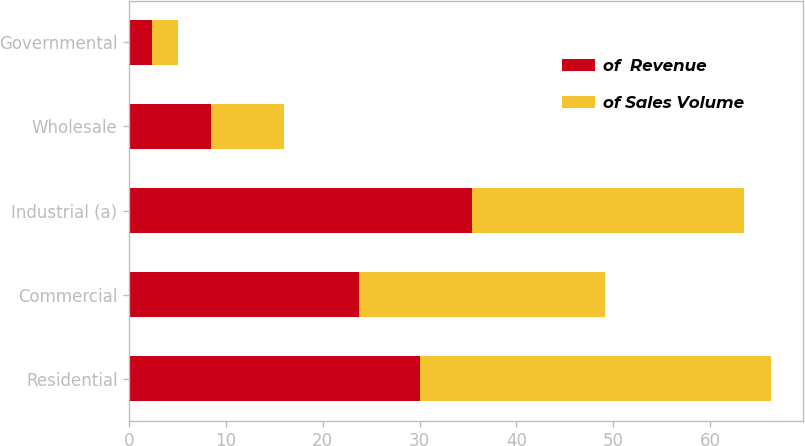<chart> <loc_0><loc_0><loc_500><loc_500><stacked_bar_chart><ecel><fcel>Residential<fcel>Commercial<fcel>Industrial (a)<fcel>Wholesale<fcel>Governmental<nl><fcel>of  Revenue<fcel>30<fcel>23.7<fcel>35.4<fcel>8.5<fcel>2.4<nl><fcel>of Sales Volume<fcel>36.3<fcel>25.5<fcel>28.1<fcel>7.5<fcel>2.6<nl></chart> 